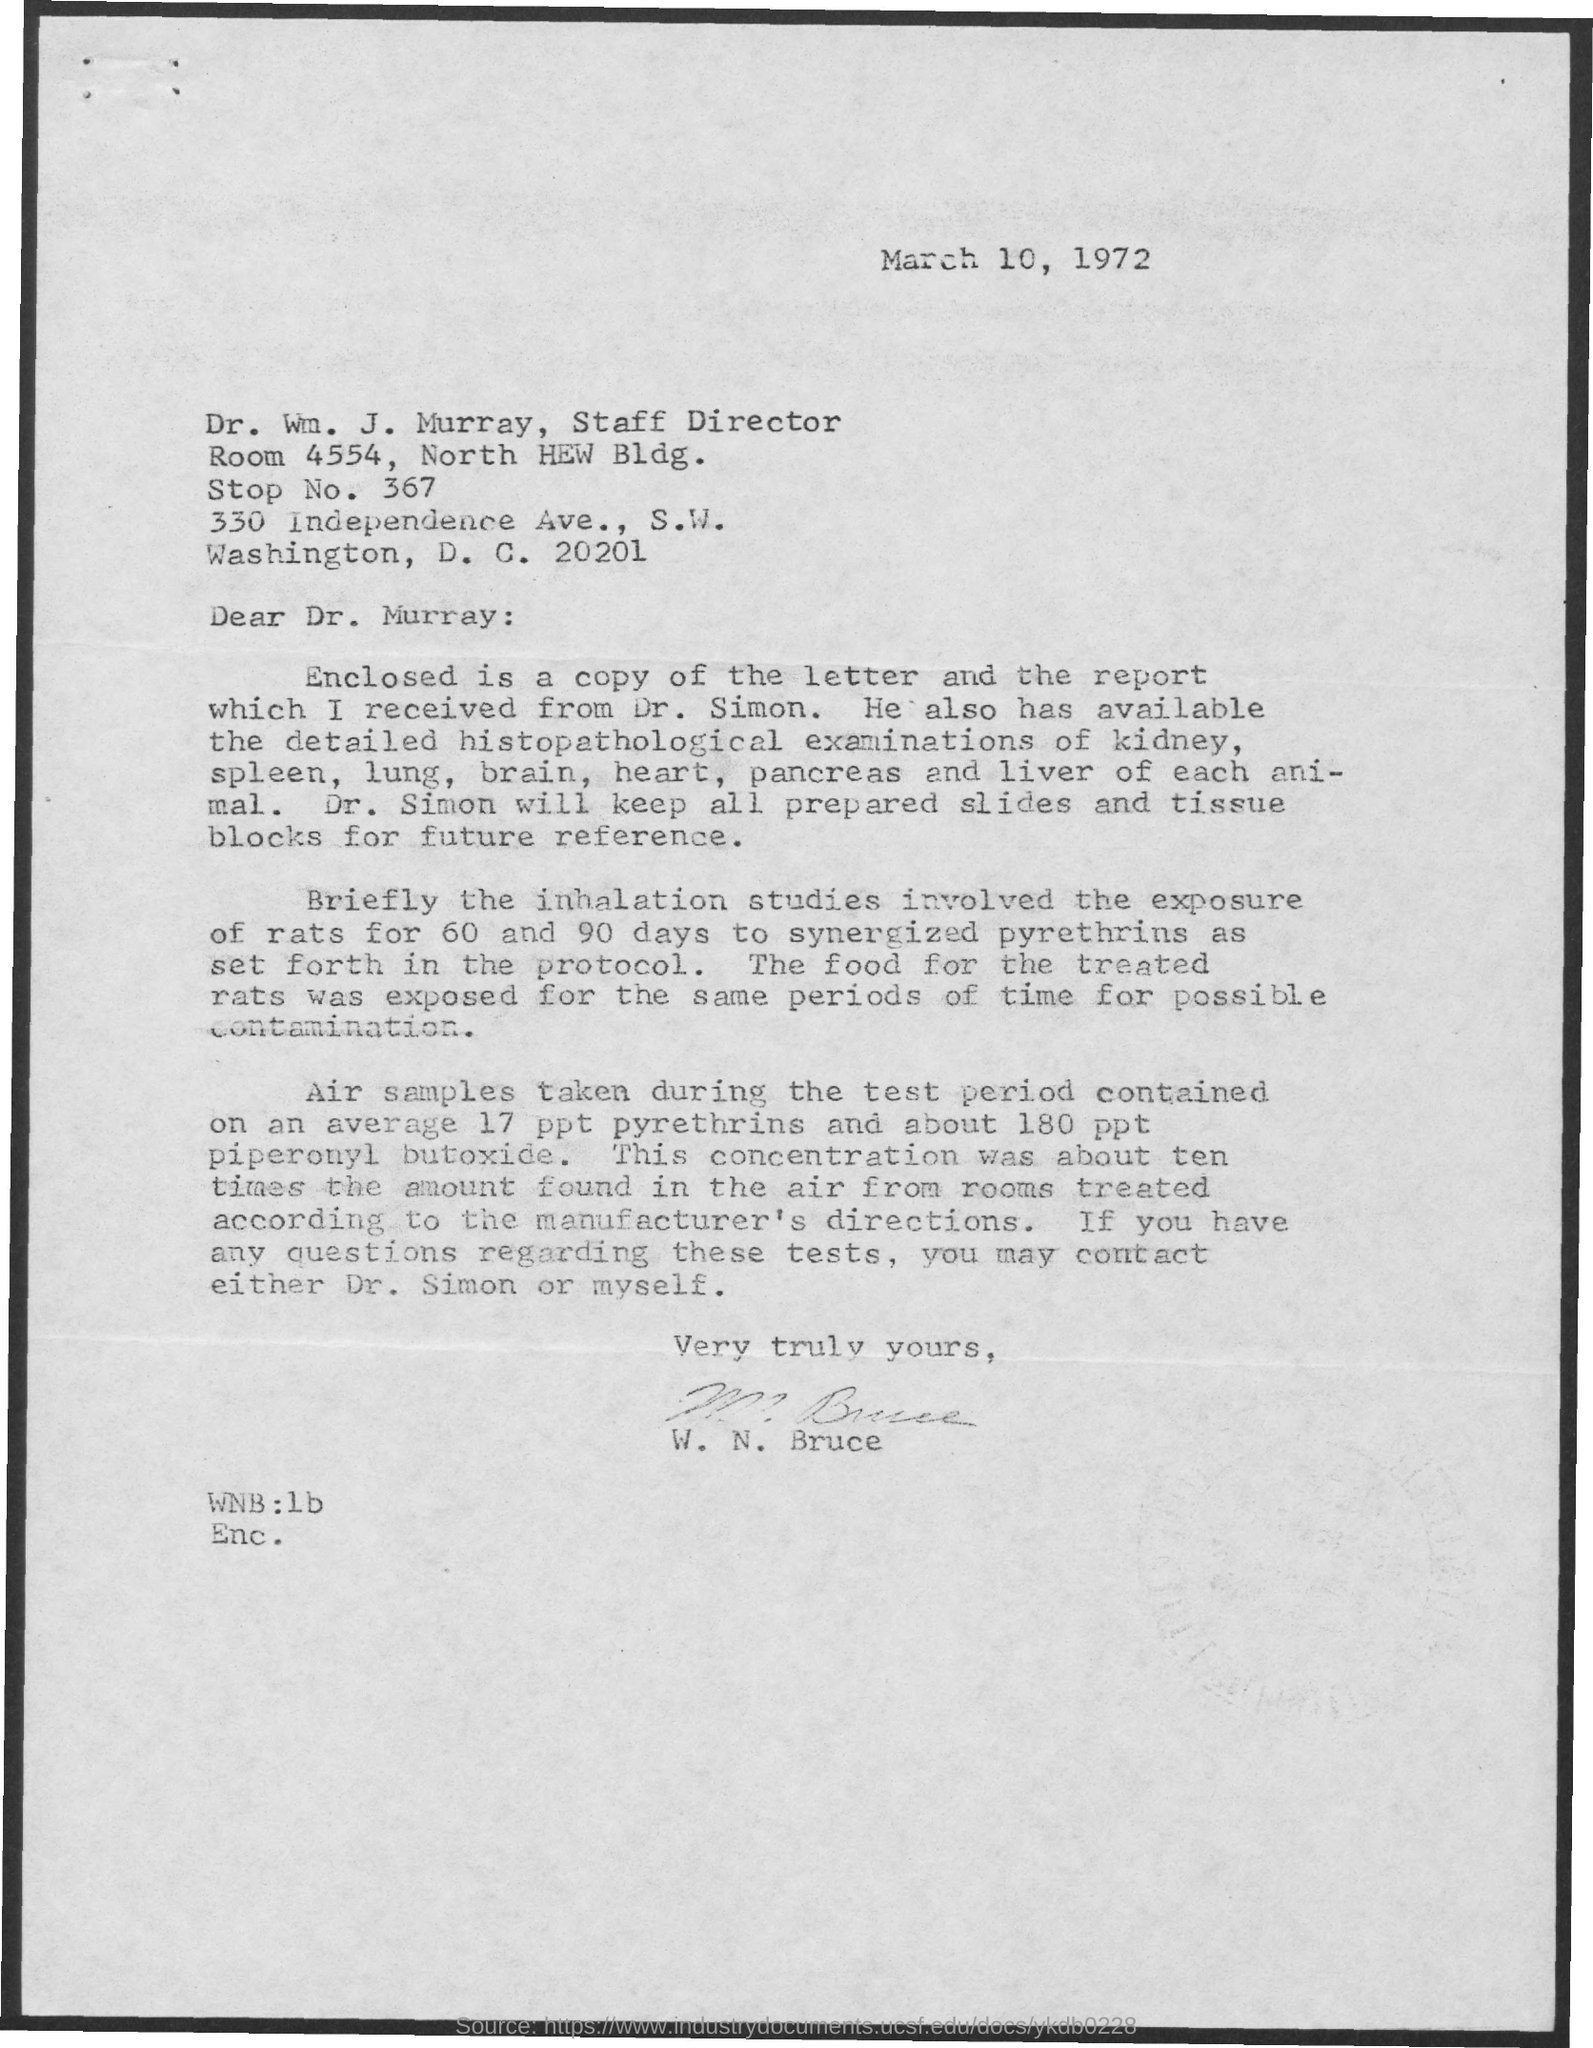What is the date mentioned
Your response must be concise. March 10, 1972. What is stop no mentioned .?
Offer a very short reply. 367. 